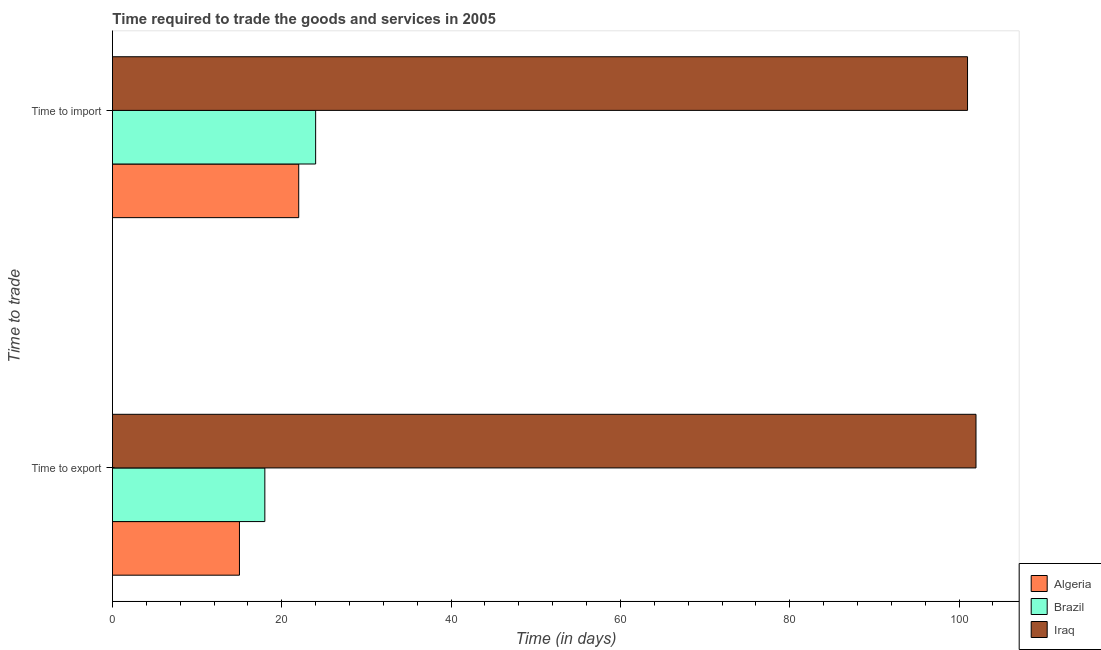How many different coloured bars are there?
Your response must be concise. 3. How many groups of bars are there?
Provide a succinct answer. 2. Are the number of bars on each tick of the Y-axis equal?
Ensure brevity in your answer.  Yes. How many bars are there on the 1st tick from the top?
Your answer should be very brief. 3. What is the label of the 2nd group of bars from the top?
Provide a short and direct response. Time to export. What is the time to export in Algeria?
Offer a terse response. 15. Across all countries, what is the maximum time to import?
Keep it short and to the point. 101. Across all countries, what is the minimum time to import?
Ensure brevity in your answer.  22. In which country was the time to import maximum?
Offer a terse response. Iraq. In which country was the time to import minimum?
Your answer should be very brief. Algeria. What is the total time to export in the graph?
Your answer should be compact. 135. What is the difference between the time to export in Brazil and that in Algeria?
Offer a very short reply. 3. What is the difference between the time to import in Brazil and the time to export in Algeria?
Ensure brevity in your answer.  9. What is the difference between the time to import and time to export in Algeria?
Your response must be concise. 7. In how many countries, is the time to export greater than 88 days?
Ensure brevity in your answer.  1. What is the ratio of the time to import in Brazil to that in Iraq?
Make the answer very short. 0.24. Is the time to import in Brazil less than that in Algeria?
Ensure brevity in your answer.  No. What does the 3rd bar from the top in Time to export represents?
Keep it short and to the point. Algeria. What does the 3rd bar from the bottom in Time to export represents?
Your answer should be compact. Iraq. How many bars are there?
Make the answer very short. 6. Does the graph contain any zero values?
Provide a short and direct response. No. Where does the legend appear in the graph?
Your response must be concise. Bottom right. How are the legend labels stacked?
Give a very brief answer. Vertical. What is the title of the graph?
Provide a succinct answer. Time required to trade the goods and services in 2005. Does "Europe(developing only)" appear as one of the legend labels in the graph?
Offer a terse response. No. What is the label or title of the X-axis?
Keep it short and to the point. Time (in days). What is the label or title of the Y-axis?
Ensure brevity in your answer.  Time to trade. What is the Time (in days) of Iraq in Time to export?
Keep it short and to the point. 102. What is the Time (in days) of Algeria in Time to import?
Ensure brevity in your answer.  22. What is the Time (in days) in Iraq in Time to import?
Give a very brief answer. 101. Across all Time to trade, what is the maximum Time (in days) in Algeria?
Offer a terse response. 22. Across all Time to trade, what is the maximum Time (in days) in Brazil?
Keep it short and to the point. 24. Across all Time to trade, what is the maximum Time (in days) in Iraq?
Provide a succinct answer. 102. Across all Time to trade, what is the minimum Time (in days) of Algeria?
Your response must be concise. 15. Across all Time to trade, what is the minimum Time (in days) in Brazil?
Ensure brevity in your answer.  18. Across all Time to trade, what is the minimum Time (in days) in Iraq?
Keep it short and to the point. 101. What is the total Time (in days) of Algeria in the graph?
Ensure brevity in your answer.  37. What is the total Time (in days) in Iraq in the graph?
Make the answer very short. 203. What is the difference between the Time (in days) of Algeria in Time to export and that in Time to import?
Keep it short and to the point. -7. What is the difference between the Time (in days) of Iraq in Time to export and that in Time to import?
Offer a very short reply. 1. What is the difference between the Time (in days) of Algeria in Time to export and the Time (in days) of Iraq in Time to import?
Your response must be concise. -86. What is the difference between the Time (in days) in Brazil in Time to export and the Time (in days) in Iraq in Time to import?
Your answer should be compact. -83. What is the average Time (in days) in Brazil per Time to trade?
Give a very brief answer. 21. What is the average Time (in days) of Iraq per Time to trade?
Ensure brevity in your answer.  101.5. What is the difference between the Time (in days) in Algeria and Time (in days) in Iraq in Time to export?
Your response must be concise. -87. What is the difference between the Time (in days) of Brazil and Time (in days) of Iraq in Time to export?
Keep it short and to the point. -84. What is the difference between the Time (in days) in Algeria and Time (in days) in Iraq in Time to import?
Give a very brief answer. -79. What is the difference between the Time (in days) in Brazil and Time (in days) in Iraq in Time to import?
Make the answer very short. -77. What is the ratio of the Time (in days) of Algeria in Time to export to that in Time to import?
Offer a terse response. 0.68. What is the ratio of the Time (in days) in Brazil in Time to export to that in Time to import?
Offer a terse response. 0.75. What is the ratio of the Time (in days) of Iraq in Time to export to that in Time to import?
Make the answer very short. 1.01. 